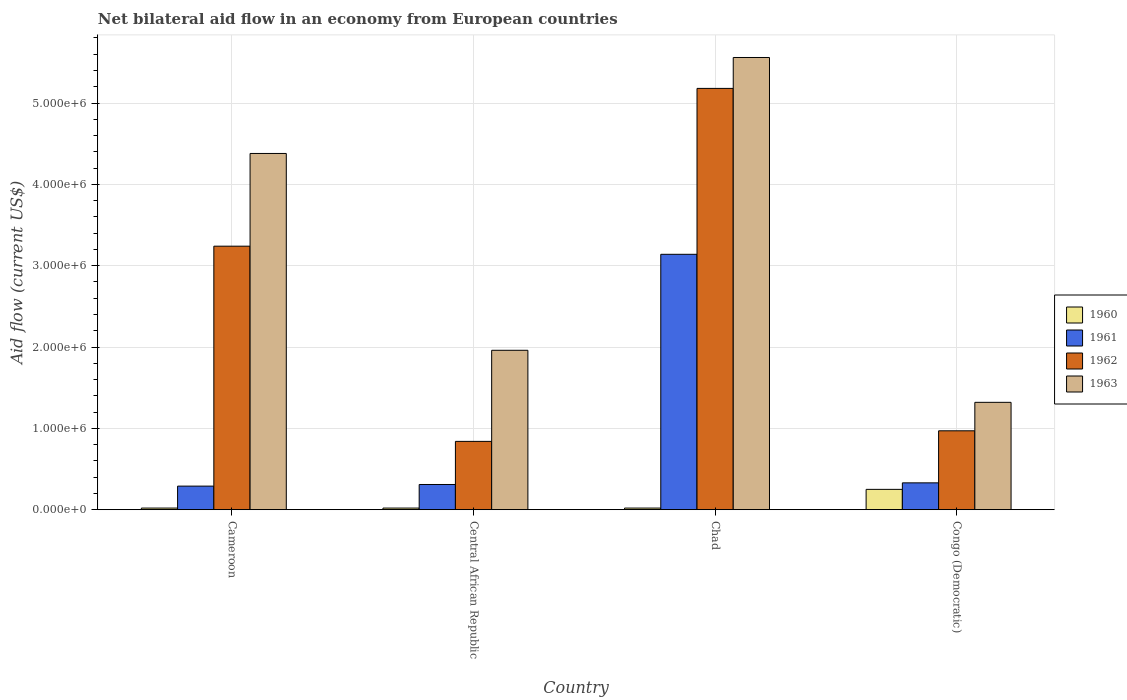How many different coloured bars are there?
Give a very brief answer. 4. Are the number of bars per tick equal to the number of legend labels?
Ensure brevity in your answer.  Yes. Are the number of bars on each tick of the X-axis equal?
Your response must be concise. Yes. How many bars are there on the 3rd tick from the right?
Offer a very short reply. 4. What is the label of the 1st group of bars from the left?
Your answer should be compact. Cameroon. Across all countries, what is the maximum net bilateral aid flow in 1960?
Keep it short and to the point. 2.50e+05. Across all countries, what is the minimum net bilateral aid flow in 1962?
Keep it short and to the point. 8.40e+05. In which country was the net bilateral aid flow in 1962 maximum?
Ensure brevity in your answer.  Chad. In which country was the net bilateral aid flow in 1963 minimum?
Provide a succinct answer. Congo (Democratic). What is the total net bilateral aid flow in 1962 in the graph?
Provide a succinct answer. 1.02e+07. What is the difference between the net bilateral aid flow in 1962 in Chad and that in Congo (Democratic)?
Offer a very short reply. 4.21e+06. What is the difference between the net bilateral aid flow in 1962 in Chad and the net bilateral aid flow in 1960 in Congo (Democratic)?
Your answer should be compact. 4.93e+06. What is the average net bilateral aid flow in 1960 per country?
Make the answer very short. 7.75e+04. What is the difference between the net bilateral aid flow of/in 1961 and net bilateral aid flow of/in 1963 in Central African Republic?
Your answer should be very brief. -1.65e+06. In how many countries, is the net bilateral aid flow in 1960 greater than 2000000 US$?
Offer a terse response. 0. What is the ratio of the net bilateral aid flow in 1962 in Chad to that in Congo (Democratic)?
Make the answer very short. 5.34. Is the difference between the net bilateral aid flow in 1961 in Cameroon and Central African Republic greater than the difference between the net bilateral aid flow in 1963 in Cameroon and Central African Republic?
Provide a succinct answer. No. What is the difference between the highest and the lowest net bilateral aid flow in 1961?
Make the answer very short. 2.85e+06. In how many countries, is the net bilateral aid flow in 1962 greater than the average net bilateral aid flow in 1962 taken over all countries?
Offer a very short reply. 2. What does the 4th bar from the left in Central African Republic represents?
Offer a terse response. 1963. How many bars are there?
Your answer should be compact. 16. Are all the bars in the graph horizontal?
Ensure brevity in your answer.  No. How many countries are there in the graph?
Offer a terse response. 4. What is the difference between two consecutive major ticks on the Y-axis?
Your answer should be compact. 1.00e+06. Does the graph contain any zero values?
Keep it short and to the point. No. Does the graph contain grids?
Offer a terse response. Yes. How are the legend labels stacked?
Make the answer very short. Vertical. What is the title of the graph?
Your answer should be very brief. Net bilateral aid flow in an economy from European countries. What is the label or title of the Y-axis?
Offer a very short reply. Aid flow (current US$). What is the Aid flow (current US$) in 1960 in Cameroon?
Provide a succinct answer. 2.00e+04. What is the Aid flow (current US$) in 1961 in Cameroon?
Offer a very short reply. 2.90e+05. What is the Aid flow (current US$) in 1962 in Cameroon?
Your answer should be very brief. 3.24e+06. What is the Aid flow (current US$) in 1963 in Cameroon?
Provide a short and direct response. 4.38e+06. What is the Aid flow (current US$) of 1962 in Central African Republic?
Keep it short and to the point. 8.40e+05. What is the Aid flow (current US$) of 1963 in Central African Republic?
Offer a very short reply. 1.96e+06. What is the Aid flow (current US$) of 1961 in Chad?
Ensure brevity in your answer.  3.14e+06. What is the Aid flow (current US$) of 1962 in Chad?
Provide a succinct answer. 5.18e+06. What is the Aid flow (current US$) of 1963 in Chad?
Give a very brief answer. 5.56e+06. What is the Aid flow (current US$) in 1960 in Congo (Democratic)?
Offer a very short reply. 2.50e+05. What is the Aid flow (current US$) in 1962 in Congo (Democratic)?
Your answer should be very brief. 9.70e+05. What is the Aid flow (current US$) of 1963 in Congo (Democratic)?
Make the answer very short. 1.32e+06. Across all countries, what is the maximum Aid flow (current US$) of 1961?
Provide a short and direct response. 3.14e+06. Across all countries, what is the maximum Aid flow (current US$) of 1962?
Provide a short and direct response. 5.18e+06. Across all countries, what is the maximum Aid flow (current US$) in 1963?
Offer a very short reply. 5.56e+06. Across all countries, what is the minimum Aid flow (current US$) of 1960?
Your answer should be compact. 2.00e+04. Across all countries, what is the minimum Aid flow (current US$) in 1962?
Offer a terse response. 8.40e+05. Across all countries, what is the minimum Aid flow (current US$) of 1963?
Give a very brief answer. 1.32e+06. What is the total Aid flow (current US$) in 1961 in the graph?
Give a very brief answer. 4.07e+06. What is the total Aid flow (current US$) in 1962 in the graph?
Give a very brief answer. 1.02e+07. What is the total Aid flow (current US$) of 1963 in the graph?
Your answer should be very brief. 1.32e+07. What is the difference between the Aid flow (current US$) in 1961 in Cameroon and that in Central African Republic?
Your answer should be very brief. -2.00e+04. What is the difference between the Aid flow (current US$) of 1962 in Cameroon and that in Central African Republic?
Offer a very short reply. 2.40e+06. What is the difference between the Aid flow (current US$) of 1963 in Cameroon and that in Central African Republic?
Offer a terse response. 2.42e+06. What is the difference between the Aid flow (current US$) in 1961 in Cameroon and that in Chad?
Keep it short and to the point. -2.85e+06. What is the difference between the Aid flow (current US$) of 1962 in Cameroon and that in Chad?
Ensure brevity in your answer.  -1.94e+06. What is the difference between the Aid flow (current US$) in 1963 in Cameroon and that in Chad?
Your answer should be compact. -1.18e+06. What is the difference between the Aid flow (current US$) of 1960 in Cameroon and that in Congo (Democratic)?
Provide a succinct answer. -2.30e+05. What is the difference between the Aid flow (current US$) in 1961 in Cameroon and that in Congo (Democratic)?
Ensure brevity in your answer.  -4.00e+04. What is the difference between the Aid flow (current US$) of 1962 in Cameroon and that in Congo (Democratic)?
Offer a very short reply. 2.27e+06. What is the difference between the Aid flow (current US$) in 1963 in Cameroon and that in Congo (Democratic)?
Offer a terse response. 3.06e+06. What is the difference between the Aid flow (current US$) in 1961 in Central African Republic and that in Chad?
Offer a terse response. -2.83e+06. What is the difference between the Aid flow (current US$) in 1962 in Central African Republic and that in Chad?
Offer a terse response. -4.34e+06. What is the difference between the Aid flow (current US$) in 1963 in Central African Republic and that in Chad?
Your answer should be compact. -3.60e+06. What is the difference between the Aid flow (current US$) in 1963 in Central African Republic and that in Congo (Democratic)?
Your response must be concise. 6.40e+05. What is the difference between the Aid flow (current US$) of 1960 in Chad and that in Congo (Democratic)?
Provide a succinct answer. -2.30e+05. What is the difference between the Aid flow (current US$) of 1961 in Chad and that in Congo (Democratic)?
Your answer should be very brief. 2.81e+06. What is the difference between the Aid flow (current US$) of 1962 in Chad and that in Congo (Democratic)?
Ensure brevity in your answer.  4.21e+06. What is the difference between the Aid flow (current US$) of 1963 in Chad and that in Congo (Democratic)?
Your answer should be very brief. 4.24e+06. What is the difference between the Aid flow (current US$) in 1960 in Cameroon and the Aid flow (current US$) in 1961 in Central African Republic?
Give a very brief answer. -2.90e+05. What is the difference between the Aid flow (current US$) of 1960 in Cameroon and the Aid flow (current US$) of 1962 in Central African Republic?
Offer a very short reply. -8.20e+05. What is the difference between the Aid flow (current US$) in 1960 in Cameroon and the Aid flow (current US$) in 1963 in Central African Republic?
Ensure brevity in your answer.  -1.94e+06. What is the difference between the Aid flow (current US$) in 1961 in Cameroon and the Aid flow (current US$) in 1962 in Central African Republic?
Your answer should be compact. -5.50e+05. What is the difference between the Aid flow (current US$) of 1961 in Cameroon and the Aid flow (current US$) of 1963 in Central African Republic?
Give a very brief answer. -1.67e+06. What is the difference between the Aid flow (current US$) in 1962 in Cameroon and the Aid flow (current US$) in 1963 in Central African Republic?
Your answer should be compact. 1.28e+06. What is the difference between the Aid flow (current US$) in 1960 in Cameroon and the Aid flow (current US$) in 1961 in Chad?
Give a very brief answer. -3.12e+06. What is the difference between the Aid flow (current US$) of 1960 in Cameroon and the Aid flow (current US$) of 1962 in Chad?
Your response must be concise. -5.16e+06. What is the difference between the Aid flow (current US$) in 1960 in Cameroon and the Aid flow (current US$) in 1963 in Chad?
Provide a succinct answer. -5.54e+06. What is the difference between the Aid flow (current US$) of 1961 in Cameroon and the Aid flow (current US$) of 1962 in Chad?
Give a very brief answer. -4.89e+06. What is the difference between the Aid flow (current US$) of 1961 in Cameroon and the Aid flow (current US$) of 1963 in Chad?
Provide a short and direct response. -5.27e+06. What is the difference between the Aid flow (current US$) of 1962 in Cameroon and the Aid flow (current US$) of 1963 in Chad?
Offer a terse response. -2.32e+06. What is the difference between the Aid flow (current US$) in 1960 in Cameroon and the Aid flow (current US$) in 1961 in Congo (Democratic)?
Offer a terse response. -3.10e+05. What is the difference between the Aid flow (current US$) in 1960 in Cameroon and the Aid flow (current US$) in 1962 in Congo (Democratic)?
Make the answer very short. -9.50e+05. What is the difference between the Aid flow (current US$) of 1960 in Cameroon and the Aid flow (current US$) of 1963 in Congo (Democratic)?
Provide a succinct answer. -1.30e+06. What is the difference between the Aid flow (current US$) in 1961 in Cameroon and the Aid flow (current US$) in 1962 in Congo (Democratic)?
Ensure brevity in your answer.  -6.80e+05. What is the difference between the Aid flow (current US$) of 1961 in Cameroon and the Aid flow (current US$) of 1963 in Congo (Democratic)?
Make the answer very short. -1.03e+06. What is the difference between the Aid flow (current US$) of 1962 in Cameroon and the Aid flow (current US$) of 1963 in Congo (Democratic)?
Keep it short and to the point. 1.92e+06. What is the difference between the Aid flow (current US$) of 1960 in Central African Republic and the Aid flow (current US$) of 1961 in Chad?
Your response must be concise. -3.12e+06. What is the difference between the Aid flow (current US$) of 1960 in Central African Republic and the Aid flow (current US$) of 1962 in Chad?
Offer a very short reply. -5.16e+06. What is the difference between the Aid flow (current US$) in 1960 in Central African Republic and the Aid flow (current US$) in 1963 in Chad?
Ensure brevity in your answer.  -5.54e+06. What is the difference between the Aid flow (current US$) of 1961 in Central African Republic and the Aid flow (current US$) of 1962 in Chad?
Your answer should be very brief. -4.87e+06. What is the difference between the Aid flow (current US$) in 1961 in Central African Republic and the Aid flow (current US$) in 1963 in Chad?
Your answer should be compact. -5.25e+06. What is the difference between the Aid flow (current US$) in 1962 in Central African Republic and the Aid flow (current US$) in 1963 in Chad?
Give a very brief answer. -4.72e+06. What is the difference between the Aid flow (current US$) of 1960 in Central African Republic and the Aid flow (current US$) of 1961 in Congo (Democratic)?
Provide a succinct answer. -3.10e+05. What is the difference between the Aid flow (current US$) in 1960 in Central African Republic and the Aid flow (current US$) in 1962 in Congo (Democratic)?
Make the answer very short. -9.50e+05. What is the difference between the Aid flow (current US$) of 1960 in Central African Republic and the Aid flow (current US$) of 1963 in Congo (Democratic)?
Offer a terse response. -1.30e+06. What is the difference between the Aid flow (current US$) in 1961 in Central African Republic and the Aid flow (current US$) in 1962 in Congo (Democratic)?
Ensure brevity in your answer.  -6.60e+05. What is the difference between the Aid flow (current US$) in 1961 in Central African Republic and the Aid flow (current US$) in 1963 in Congo (Democratic)?
Provide a succinct answer. -1.01e+06. What is the difference between the Aid flow (current US$) in 1962 in Central African Republic and the Aid flow (current US$) in 1963 in Congo (Democratic)?
Ensure brevity in your answer.  -4.80e+05. What is the difference between the Aid flow (current US$) of 1960 in Chad and the Aid flow (current US$) of 1961 in Congo (Democratic)?
Your answer should be very brief. -3.10e+05. What is the difference between the Aid flow (current US$) of 1960 in Chad and the Aid flow (current US$) of 1962 in Congo (Democratic)?
Provide a succinct answer. -9.50e+05. What is the difference between the Aid flow (current US$) in 1960 in Chad and the Aid flow (current US$) in 1963 in Congo (Democratic)?
Your answer should be compact. -1.30e+06. What is the difference between the Aid flow (current US$) in 1961 in Chad and the Aid flow (current US$) in 1962 in Congo (Democratic)?
Your answer should be compact. 2.17e+06. What is the difference between the Aid flow (current US$) of 1961 in Chad and the Aid flow (current US$) of 1963 in Congo (Democratic)?
Ensure brevity in your answer.  1.82e+06. What is the difference between the Aid flow (current US$) in 1962 in Chad and the Aid flow (current US$) in 1963 in Congo (Democratic)?
Make the answer very short. 3.86e+06. What is the average Aid flow (current US$) of 1960 per country?
Make the answer very short. 7.75e+04. What is the average Aid flow (current US$) of 1961 per country?
Make the answer very short. 1.02e+06. What is the average Aid flow (current US$) of 1962 per country?
Offer a terse response. 2.56e+06. What is the average Aid flow (current US$) of 1963 per country?
Your answer should be very brief. 3.30e+06. What is the difference between the Aid flow (current US$) in 1960 and Aid flow (current US$) in 1961 in Cameroon?
Make the answer very short. -2.70e+05. What is the difference between the Aid flow (current US$) of 1960 and Aid flow (current US$) of 1962 in Cameroon?
Provide a succinct answer. -3.22e+06. What is the difference between the Aid flow (current US$) in 1960 and Aid flow (current US$) in 1963 in Cameroon?
Your answer should be compact. -4.36e+06. What is the difference between the Aid flow (current US$) of 1961 and Aid flow (current US$) of 1962 in Cameroon?
Ensure brevity in your answer.  -2.95e+06. What is the difference between the Aid flow (current US$) of 1961 and Aid flow (current US$) of 1963 in Cameroon?
Make the answer very short. -4.09e+06. What is the difference between the Aid flow (current US$) of 1962 and Aid flow (current US$) of 1963 in Cameroon?
Offer a very short reply. -1.14e+06. What is the difference between the Aid flow (current US$) of 1960 and Aid flow (current US$) of 1961 in Central African Republic?
Your answer should be compact. -2.90e+05. What is the difference between the Aid flow (current US$) of 1960 and Aid flow (current US$) of 1962 in Central African Republic?
Keep it short and to the point. -8.20e+05. What is the difference between the Aid flow (current US$) of 1960 and Aid flow (current US$) of 1963 in Central African Republic?
Provide a succinct answer. -1.94e+06. What is the difference between the Aid flow (current US$) of 1961 and Aid flow (current US$) of 1962 in Central African Republic?
Provide a succinct answer. -5.30e+05. What is the difference between the Aid flow (current US$) of 1961 and Aid flow (current US$) of 1963 in Central African Republic?
Your answer should be very brief. -1.65e+06. What is the difference between the Aid flow (current US$) in 1962 and Aid flow (current US$) in 1963 in Central African Republic?
Your answer should be very brief. -1.12e+06. What is the difference between the Aid flow (current US$) of 1960 and Aid flow (current US$) of 1961 in Chad?
Provide a succinct answer. -3.12e+06. What is the difference between the Aid flow (current US$) of 1960 and Aid flow (current US$) of 1962 in Chad?
Your response must be concise. -5.16e+06. What is the difference between the Aid flow (current US$) in 1960 and Aid flow (current US$) in 1963 in Chad?
Offer a terse response. -5.54e+06. What is the difference between the Aid flow (current US$) in 1961 and Aid flow (current US$) in 1962 in Chad?
Your response must be concise. -2.04e+06. What is the difference between the Aid flow (current US$) of 1961 and Aid flow (current US$) of 1963 in Chad?
Ensure brevity in your answer.  -2.42e+06. What is the difference between the Aid flow (current US$) in 1962 and Aid flow (current US$) in 1963 in Chad?
Your answer should be compact. -3.80e+05. What is the difference between the Aid flow (current US$) in 1960 and Aid flow (current US$) in 1961 in Congo (Democratic)?
Make the answer very short. -8.00e+04. What is the difference between the Aid flow (current US$) in 1960 and Aid flow (current US$) in 1962 in Congo (Democratic)?
Offer a terse response. -7.20e+05. What is the difference between the Aid flow (current US$) in 1960 and Aid flow (current US$) in 1963 in Congo (Democratic)?
Your answer should be very brief. -1.07e+06. What is the difference between the Aid flow (current US$) of 1961 and Aid flow (current US$) of 1962 in Congo (Democratic)?
Offer a terse response. -6.40e+05. What is the difference between the Aid flow (current US$) in 1961 and Aid flow (current US$) in 1963 in Congo (Democratic)?
Make the answer very short. -9.90e+05. What is the difference between the Aid flow (current US$) of 1962 and Aid flow (current US$) of 1963 in Congo (Democratic)?
Offer a terse response. -3.50e+05. What is the ratio of the Aid flow (current US$) of 1961 in Cameroon to that in Central African Republic?
Make the answer very short. 0.94. What is the ratio of the Aid flow (current US$) in 1962 in Cameroon to that in Central African Republic?
Offer a very short reply. 3.86. What is the ratio of the Aid flow (current US$) in 1963 in Cameroon to that in Central African Republic?
Offer a very short reply. 2.23. What is the ratio of the Aid flow (current US$) of 1960 in Cameroon to that in Chad?
Your response must be concise. 1. What is the ratio of the Aid flow (current US$) in 1961 in Cameroon to that in Chad?
Give a very brief answer. 0.09. What is the ratio of the Aid flow (current US$) in 1962 in Cameroon to that in Chad?
Your response must be concise. 0.63. What is the ratio of the Aid flow (current US$) in 1963 in Cameroon to that in Chad?
Offer a terse response. 0.79. What is the ratio of the Aid flow (current US$) of 1960 in Cameroon to that in Congo (Democratic)?
Provide a short and direct response. 0.08. What is the ratio of the Aid flow (current US$) of 1961 in Cameroon to that in Congo (Democratic)?
Your response must be concise. 0.88. What is the ratio of the Aid flow (current US$) in 1962 in Cameroon to that in Congo (Democratic)?
Provide a short and direct response. 3.34. What is the ratio of the Aid flow (current US$) in 1963 in Cameroon to that in Congo (Democratic)?
Your answer should be compact. 3.32. What is the ratio of the Aid flow (current US$) in 1961 in Central African Republic to that in Chad?
Give a very brief answer. 0.1. What is the ratio of the Aid flow (current US$) of 1962 in Central African Republic to that in Chad?
Offer a very short reply. 0.16. What is the ratio of the Aid flow (current US$) of 1963 in Central African Republic to that in Chad?
Ensure brevity in your answer.  0.35. What is the ratio of the Aid flow (current US$) in 1961 in Central African Republic to that in Congo (Democratic)?
Keep it short and to the point. 0.94. What is the ratio of the Aid flow (current US$) of 1962 in Central African Republic to that in Congo (Democratic)?
Offer a very short reply. 0.87. What is the ratio of the Aid flow (current US$) of 1963 in Central African Republic to that in Congo (Democratic)?
Offer a terse response. 1.48. What is the ratio of the Aid flow (current US$) in 1961 in Chad to that in Congo (Democratic)?
Give a very brief answer. 9.52. What is the ratio of the Aid flow (current US$) of 1962 in Chad to that in Congo (Democratic)?
Offer a terse response. 5.34. What is the ratio of the Aid flow (current US$) of 1963 in Chad to that in Congo (Democratic)?
Offer a very short reply. 4.21. What is the difference between the highest and the second highest Aid flow (current US$) in 1960?
Offer a very short reply. 2.30e+05. What is the difference between the highest and the second highest Aid flow (current US$) in 1961?
Offer a very short reply. 2.81e+06. What is the difference between the highest and the second highest Aid flow (current US$) of 1962?
Provide a succinct answer. 1.94e+06. What is the difference between the highest and the second highest Aid flow (current US$) of 1963?
Offer a very short reply. 1.18e+06. What is the difference between the highest and the lowest Aid flow (current US$) of 1961?
Your answer should be compact. 2.85e+06. What is the difference between the highest and the lowest Aid flow (current US$) in 1962?
Your response must be concise. 4.34e+06. What is the difference between the highest and the lowest Aid flow (current US$) in 1963?
Your answer should be compact. 4.24e+06. 